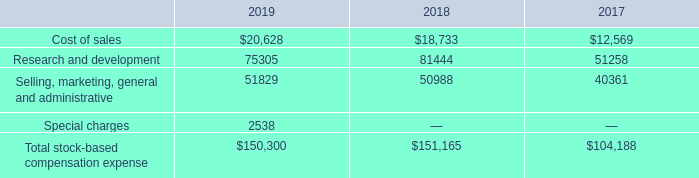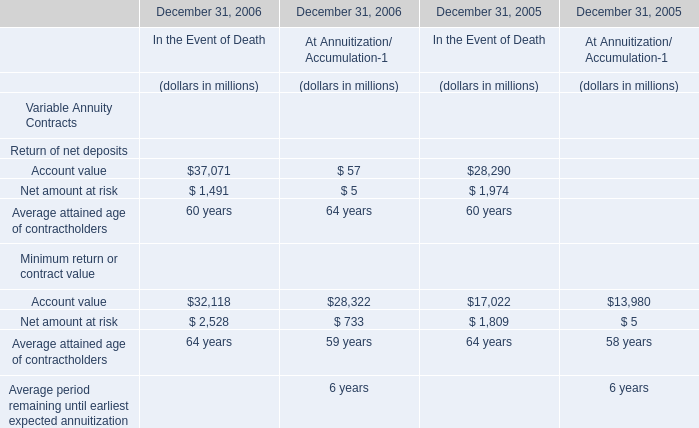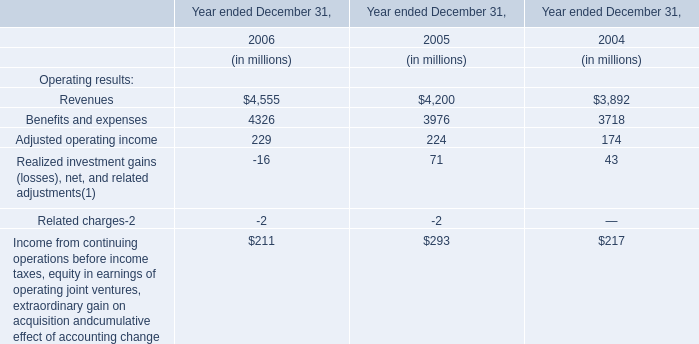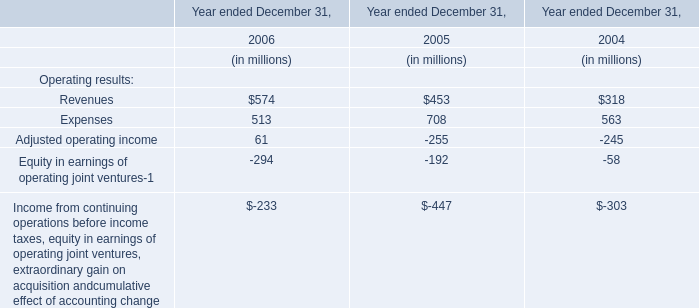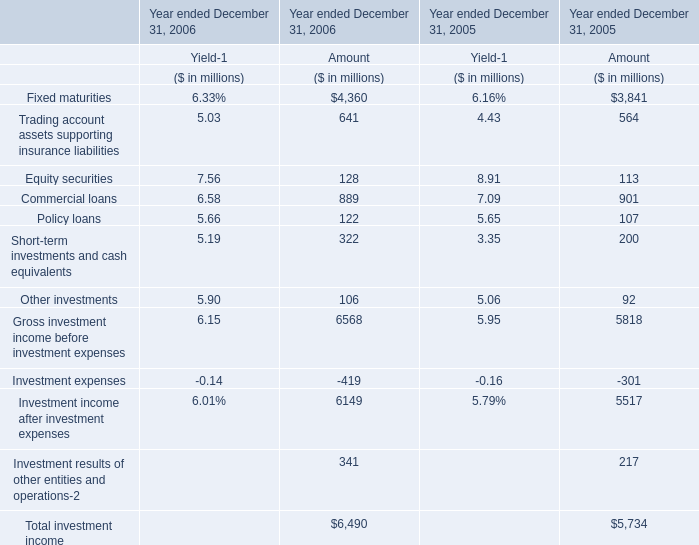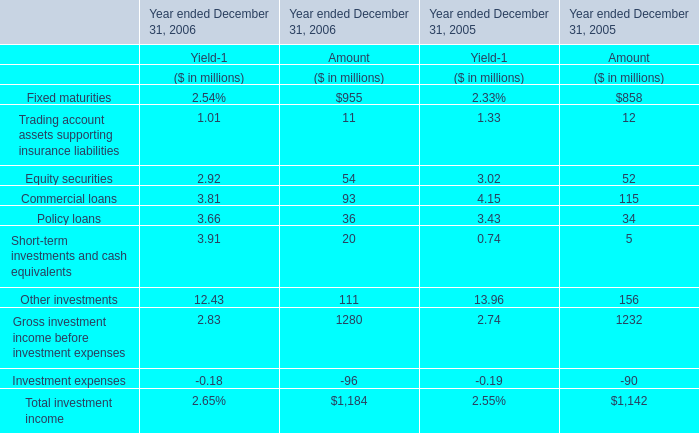Which element makes up more than 10% of the total for Amout in 2005? 
Answer: Fixed maturities, Commercial loans. 